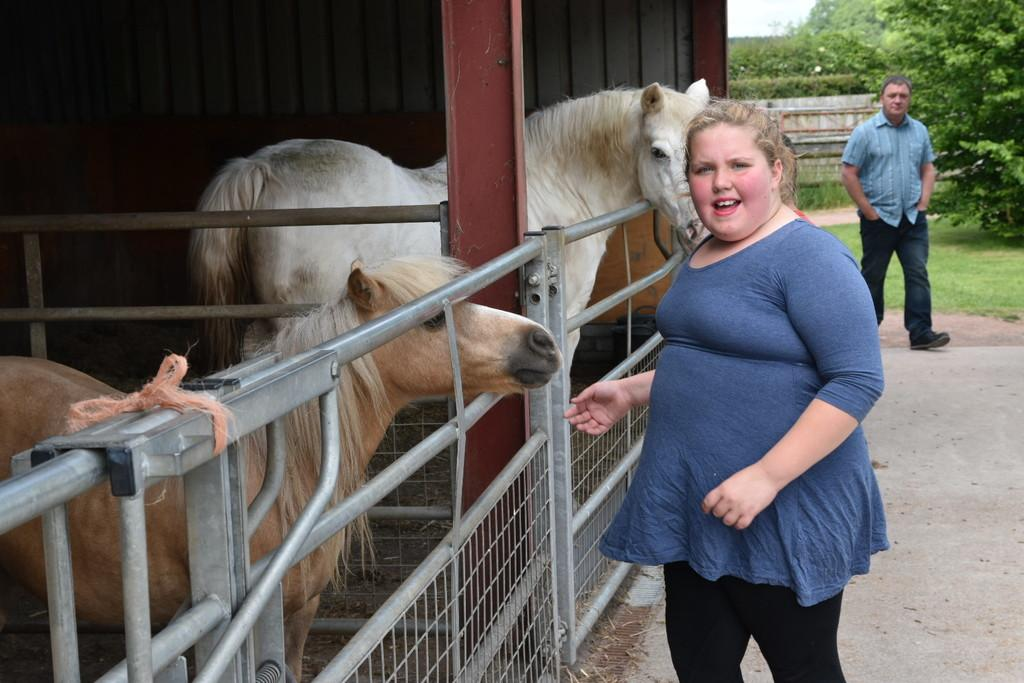What type of structure is present in the image? There is a shed in the image. What animals can be seen in the image? There are horses in the image. What type of fencing is visible in the image? There are railings with rods in the image. How many people are present in the image? There are two persons in the image. What can be seen in the background of the image? There are trees in the background of the image. What color is the cub's tongue in the image? There is no cub present in the image, so it is not possible to determine the color of its tongue. 